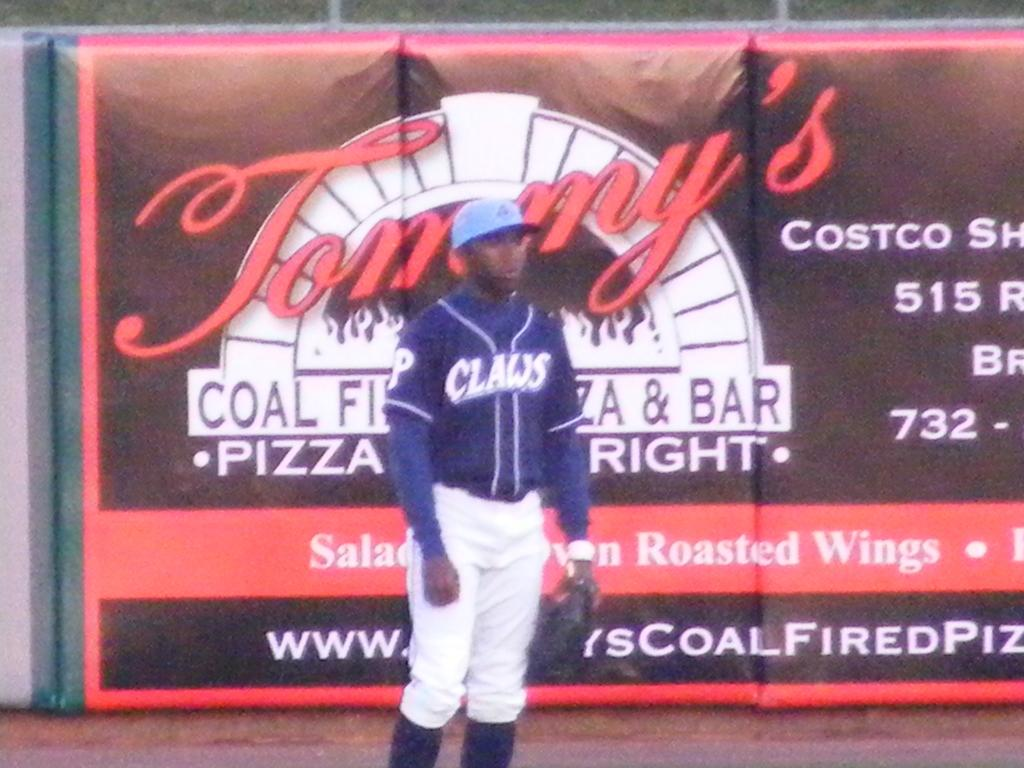<image>
Describe the image concisely. A baseball player wear a Claws uniform stands in front of a Tommy's pizza advertisement. 